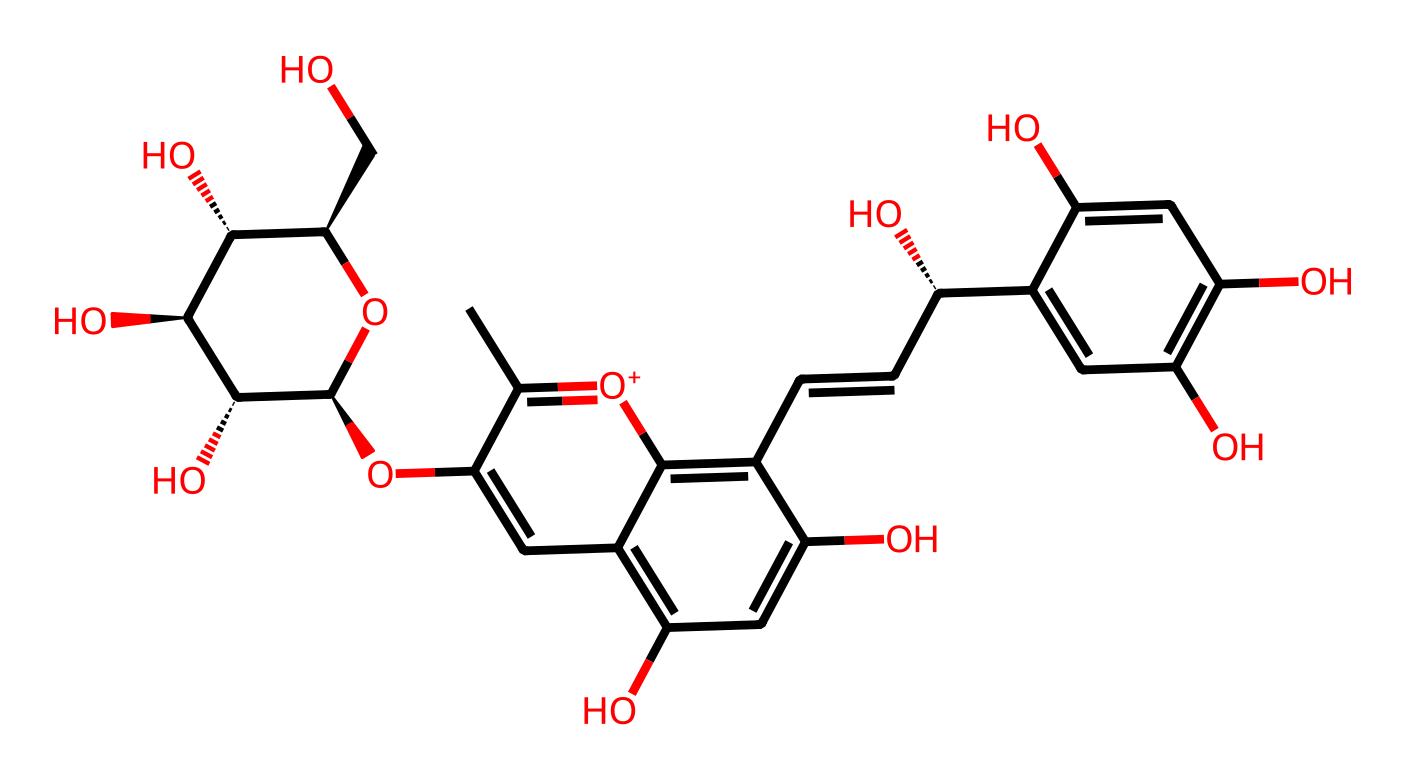What is the main functional group present in this molecule? The molecule contains multiple hydroxyl groups (–OH) which are indicative of phenolic structures commonly found in anthocyanins. These groups are responsible for the antioxidant activity of the compound.
Answer: hydroxyl group How many carbon atoms are in the structure? By counting the carbon atoms represented throughout the entire SMILES notation, there are 21 carbon atoms in total.
Answer: 21 What is the significance of the 'C=C' bond in this molecule? The 'C=C' bond indicates a double bond between carbon atoms, which is important for the stability and reactivity of the anthocyanin, allowing for possible interactions with free radicals.
Answer: stability and reactivity How many hydroxyl groups are present in this structure? By identifying the hydroxyl groups (–OH) in the SMILES, we find there are 6 hydroxyl groups present in different parts of the molecule.
Answer: 6 Which part of the molecule contributes to its color? The conjugated double bonds (the alternating single and double bonds, particularly around the aromatic rings) are responsible for the color of anthocyanins due to their ability to absorb visible light.
Answer: conjugated double bonds What type of antioxidant properties does this molecule exhibit? This anthocyanin exhibits scavenging properties due to its ability to donate electrons from the hydroxyl groups, thus neutralizing free radicals.
Answer: scavenging properties 